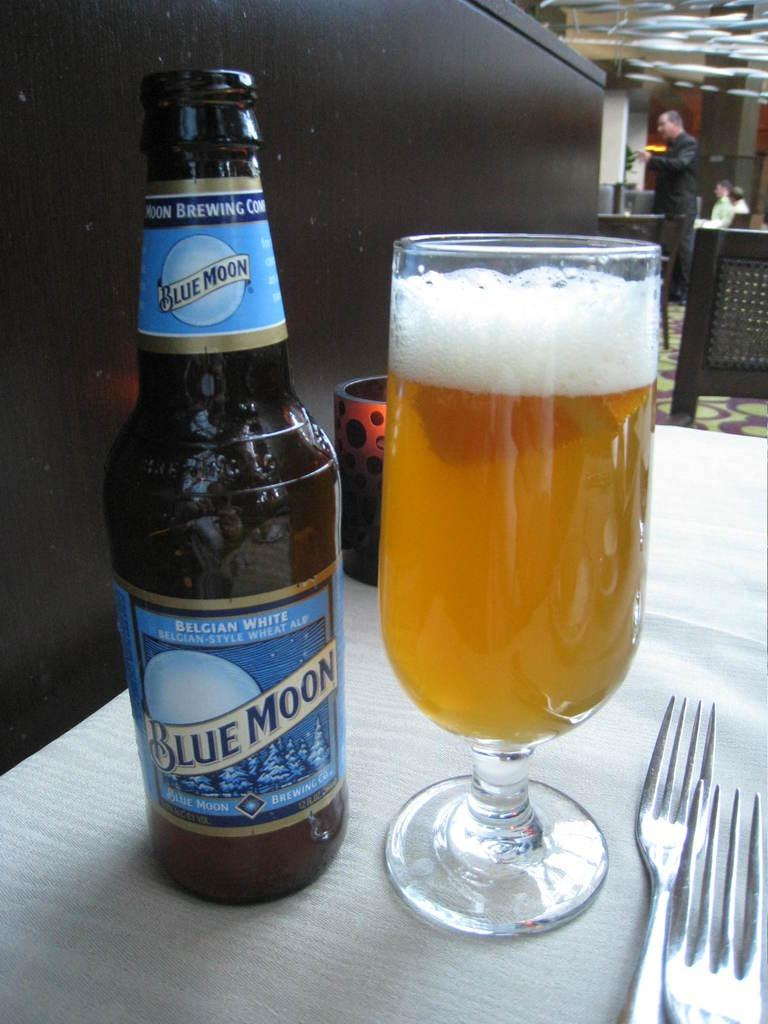Provide a one-sentence caption for the provided image. An open bottle of Blue Moon ale with a full glass next to it. 